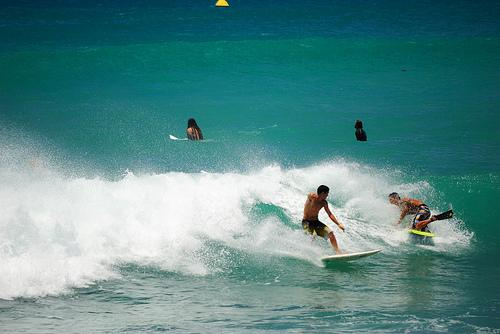How many people are in the water, according to the annotations? There are at least eight instances of people in the water mentioned. Describe a prominent feature of the ocean water in this image. The ocean water has large white and green waves crashing, creating a vibrant scene. Write a brief sentence describing the interaction between the surfer and the ocean. The surfer is skillfully riding the white and green ocean waves while maintaining balance on a surfboard. What time of day does the scene appear to be taking place? The scene appears to be during the day time. Can you identify any sentiment or emotion from the scene in the image? The image evokes a sense of excitement and adventure. What are the main colors seen in the water? The main colors in the water are blue, green, and white. List five objects that can be found in the photo. Surfer, white and green ocean waves, surfboards, water splash, multicolor shorts Count the number of white and green ocean waves mentioned in the annotations. There are nine white and green ocean waves mentioned. 